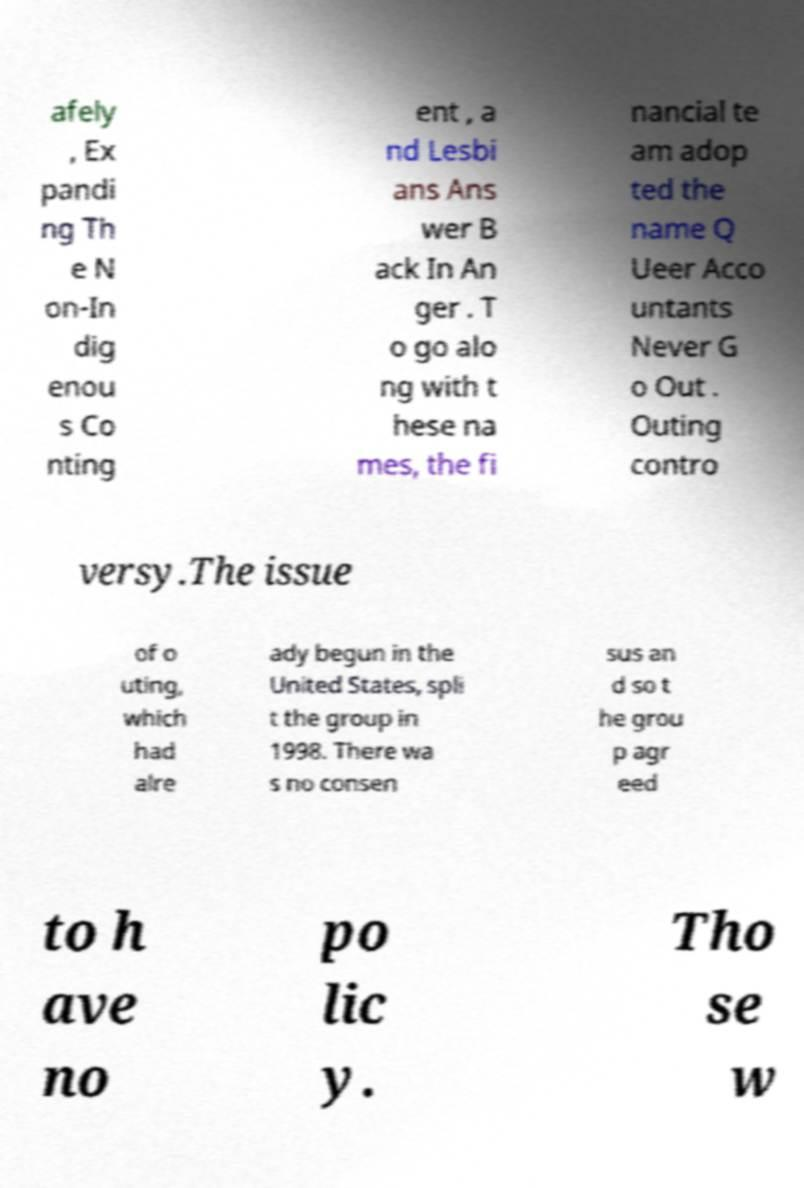I need the written content from this picture converted into text. Can you do that? afely , Ex pandi ng Th e N on-In dig enou s Co nting ent , a nd Lesbi ans Ans wer B ack In An ger . T o go alo ng with t hese na mes, the fi nancial te am adop ted the name Q Ueer Acco untants Never G o Out . Outing contro versy.The issue of o uting, which had alre ady begun in the United States, spli t the group in 1998. There wa s no consen sus an d so t he grou p agr eed to h ave no po lic y. Tho se w 